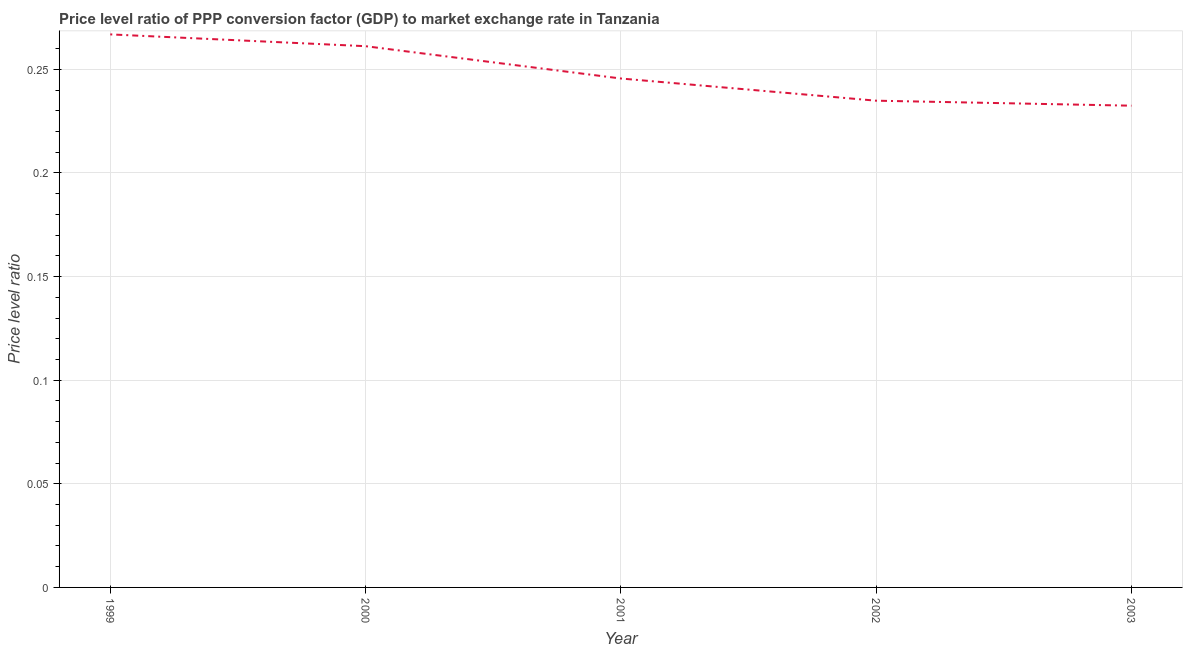What is the price level ratio in 2000?
Provide a short and direct response. 0.26. Across all years, what is the maximum price level ratio?
Keep it short and to the point. 0.27. Across all years, what is the minimum price level ratio?
Your response must be concise. 0.23. In which year was the price level ratio maximum?
Offer a terse response. 1999. What is the sum of the price level ratio?
Give a very brief answer. 1.24. What is the difference between the price level ratio in 1999 and 2003?
Provide a short and direct response. 0.03. What is the average price level ratio per year?
Give a very brief answer. 0.25. What is the median price level ratio?
Make the answer very short. 0.25. In how many years, is the price level ratio greater than 0.09 ?
Give a very brief answer. 5. What is the ratio of the price level ratio in 2000 to that in 2002?
Your answer should be compact. 1.11. Is the price level ratio in 1999 less than that in 2002?
Your answer should be compact. No. What is the difference between the highest and the second highest price level ratio?
Ensure brevity in your answer.  0.01. Is the sum of the price level ratio in 1999 and 2002 greater than the maximum price level ratio across all years?
Make the answer very short. Yes. What is the difference between the highest and the lowest price level ratio?
Provide a short and direct response. 0.03. In how many years, is the price level ratio greater than the average price level ratio taken over all years?
Make the answer very short. 2. Does the price level ratio monotonically increase over the years?
Give a very brief answer. No. How many lines are there?
Provide a short and direct response. 1. What is the difference between two consecutive major ticks on the Y-axis?
Keep it short and to the point. 0.05. Are the values on the major ticks of Y-axis written in scientific E-notation?
Your answer should be compact. No. Does the graph contain grids?
Keep it short and to the point. Yes. What is the title of the graph?
Keep it short and to the point. Price level ratio of PPP conversion factor (GDP) to market exchange rate in Tanzania. What is the label or title of the Y-axis?
Your answer should be compact. Price level ratio. What is the Price level ratio of 1999?
Provide a succinct answer. 0.27. What is the Price level ratio of 2000?
Keep it short and to the point. 0.26. What is the Price level ratio of 2001?
Offer a very short reply. 0.25. What is the Price level ratio of 2002?
Offer a terse response. 0.23. What is the Price level ratio of 2003?
Make the answer very short. 0.23. What is the difference between the Price level ratio in 1999 and 2000?
Keep it short and to the point. 0.01. What is the difference between the Price level ratio in 1999 and 2001?
Offer a very short reply. 0.02. What is the difference between the Price level ratio in 1999 and 2002?
Offer a very short reply. 0.03. What is the difference between the Price level ratio in 1999 and 2003?
Give a very brief answer. 0.03. What is the difference between the Price level ratio in 2000 and 2001?
Provide a short and direct response. 0.02. What is the difference between the Price level ratio in 2000 and 2002?
Give a very brief answer. 0.03. What is the difference between the Price level ratio in 2000 and 2003?
Offer a terse response. 0.03. What is the difference between the Price level ratio in 2001 and 2002?
Make the answer very short. 0.01. What is the difference between the Price level ratio in 2001 and 2003?
Make the answer very short. 0.01. What is the difference between the Price level ratio in 2002 and 2003?
Provide a short and direct response. 0. What is the ratio of the Price level ratio in 1999 to that in 2001?
Provide a succinct answer. 1.09. What is the ratio of the Price level ratio in 1999 to that in 2002?
Provide a succinct answer. 1.14. What is the ratio of the Price level ratio in 1999 to that in 2003?
Give a very brief answer. 1.15. What is the ratio of the Price level ratio in 2000 to that in 2001?
Offer a very short reply. 1.06. What is the ratio of the Price level ratio in 2000 to that in 2002?
Your answer should be compact. 1.11. What is the ratio of the Price level ratio in 2000 to that in 2003?
Keep it short and to the point. 1.12. What is the ratio of the Price level ratio in 2001 to that in 2002?
Provide a short and direct response. 1.05. What is the ratio of the Price level ratio in 2001 to that in 2003?
Your answer should be compact. 1.06. 